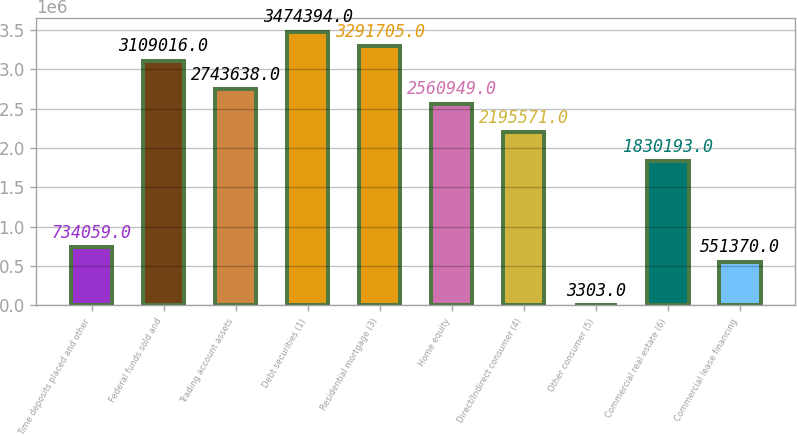Convert chart. <chart><loc_0><loc_0><loc_500><loc_500><bar_chart><fcel>Time deposits placed and other<fcel>Federal funds sold and<fcel>Trading account assets<fcel>Debt securities (1)<fcel>Residential mortgage (3)<fcel>Home equity<fcel>Direct/Indirect consumer (4)<fcel>Other consumer (5)<fcel>Commercial real estate (6)<fcel>Commercial lease financing<nl><fcel>734059<fcel>3.10902e+06<fcel>2.74364e+06<fcel>3.47439e+06<fcel>3.2917e+06<fcel>2.56095e+06<fcel>2.19557e+06<fcel>3303<fcel>1.83019e+06<fcel>551370<nl></chart> 